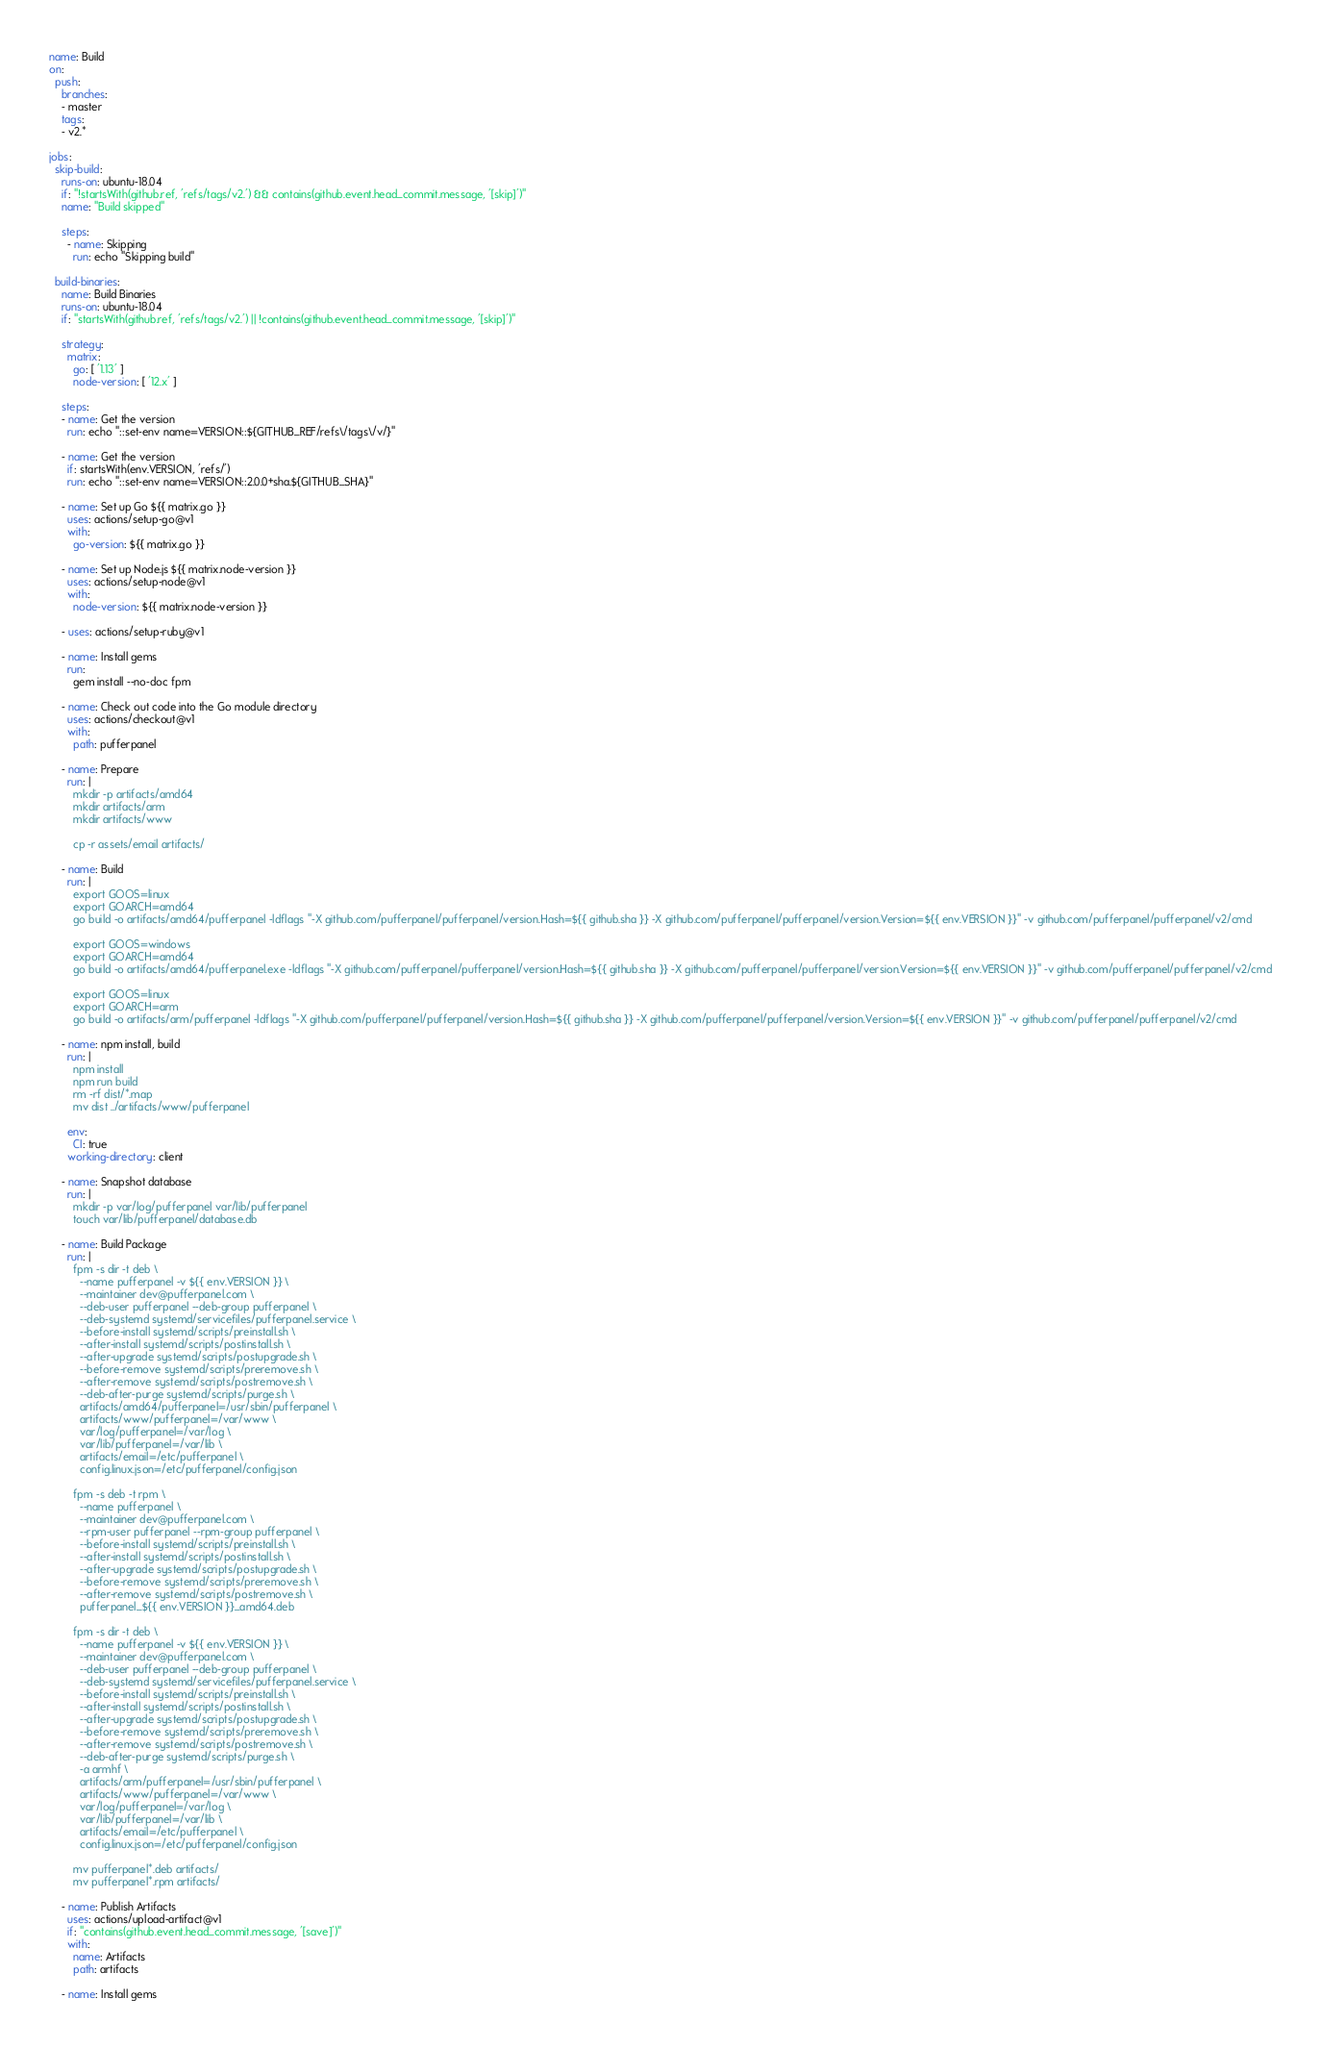<code> <loc_0><loc_0><loc_500><loc_500><_YAML_>name: Build
on: 
  push:
    branches:
    - master
    tags:
    - v2.*
    
jobs:
  skip-build:
    runs-on: ubuntu-18.04
    if: "!startsWith(github.ref, 'refs/tags/v2.') && contains(github.event.head_commit.message, '[skip]')"
    name: "Build skipped"

    steps:
      - name: Skipping
        run: echo "Skipping build"

  build-binaries:
    name: Build Binaries
    runs-on: ubuntu-18.04
    if: "startsWith(github.ref, 'refs/tags/v2.') || !contains(github.event.head_commit.message, '[skip]')"
    
    strategy:
      matrix:
        go: [ '1.13' ]
        node-version: [ '12.x' ]

    steps:
    - name: Get the version
      run: echo "::set-env name=VERSION::${GITHUB_REF/refs\/tags\/v/}"
    
    - name: Get the version
      if: startsWith(env.VERSION, 'refs/')
      run: echo "::set-env name=VERSION::2.0.0+sha.${GITHUB_SHA}"

    - name: Set up Go ${{ matrix.go }}
      uses: actions/setup-go@v1
      with:
        go-version: ${{ matrix.go }}

    - name: Set up Node.js ${{ matrix.node-version }}
      uses: actions/setup-node@v1
      with:
        node-version: ${{ matrix.node-version }}

    - uses: actions/setup-ruby@v1

    - name: Install gems
      run:
        gem install --no-doc fpm

    - name: Check out code into the Go module directory
      uses: actions/checkout@v1
      with:
        path: pufferpanel

    - name: Prepare
      run: |
        mkdir -p artifacts/amd64
        mkdir artifacts/arm
        mkdir artifacts/www

        cp -r assets/email artifacts/
        
    - name: Build
      run: |
        export GOOS=linux
        export GOARCH=amd64
        go build -o artifacts/amd64/pufferpanel -ldflags "-X github.com/pufferpanel/pufferpanel/version.Hash=${{ github.sha }} -X github.com/pufferpanel/pufferpanel/version.Version=${{ env.VERSION }}" -v github.com/pufferpanel/pufferpanel/v2/cmd

        export GOOS=windows
        export GOARCH=amd64
        go build -o artifacts/amd64/pufferpanel.exe -ldflags "-X github.com/pufferpanel/pufferpanel/version.Hash=${{ github.sha }} -X github.com/pufferpanel/pufferpanel/version.Version=${{ env.VERSION }}" -v github.com/pufferpanel/pufferpanel/v2/cmd

        export GOOS=linux
        export GOARCH=arm
        go build -o artifacts/arm/pufferpanel -ldflags "-X github.com/pufferpanel/pufferpanel/version.Hash=${{ github.sha }} -X github.com/pufferpanel/pufferpanel/version.Version=${{ env.VERSION }}" -v github.com/pufferpanel/pufferpanel/v2/cmd

    - name: npm install, build
      run: |
        npm install
        npm run build
        rm -rf dist/*.map
        mv dist ../artifacts/www/pufferpanel

      env:
        CI: true
      working-directory: client
  
    - name: Snapshot database
      run: |
        mkdir -p var/log/pufferpanel var/lib/pufferpanel
        touch var/lib/pufferpanel/database.db

    - name: Build Package
      run: |
        fpm -s dir -t deb \
          --name pufferpanel -v ${{ env.VERSION }} \
          --maintainer dev@pufferpanel.com \
          --deb-user pufferpanel --deb-group pufferpanel \
          --deb-systemd systemd/servicefiles/pufferpanel.service \
          --before-install systemd/scripts/preinstall.sh \
          --after-install systemd/scripts/postinstall.sh \
          --after-upgrade systemd/scripts/postupgrade.sh \
          --before-remove systemd/scripts/preremove.sh \
          --after-remove systemd/scripts/postremove.sh \
          --deb-after-purge systemd/scripts/purge.sh \
          artifacts/amd64/pufferpanel=/usr/sbin/pufferpanel \
          artifacts/www/pufferpanel=/var/www \
          var/log/pufferpanel=/var/log \
          var/lib/pufferpanel=/var/lib \
          artifacts/email=/etc/pufferpanel \
          config.linux.json=/etc/pufferpanel/config.json

        fpm -s deb -t rpm \
          --name pufferpanel \
          --maintainer dev@pufferpanel.com \
          --rpm-user pufferpanel --rpm-group pufferpanel \
          --before-install systemd/scripts/preinstall.sh \
          --after-install systemd/scripts/postinstall.sh \
          --after-upgrade systemd/scripts/postupgrade.sh \
          --before-remove systemd/scripts/preremove.sh \
          --after-remove systemd/scripts/postremove.sh \
          pufferpanel_${{ env.VERSION }}_amd64.deb

        fpm -s dir -t deb \
          --name pufferpanel -v ${{ env.VERSION }} \
          --maintainer dev@pufferpanel.com \
          --deb-user pufferpanel --deb-group pufferpanel \
          --deb-systemd systemd/servicefiles/pufferpanel.service \
          --before-install systemd/scripts/preinstall.sh \
          --after-install systemd/scripts/postinstall.sh \
          --after-upgrade systemd/scripts/postupgrade.sh \
          --before-remove systemd/scripts/preremove.sh \
          --after-remove systemd/scripts/postremove.sh \
          --deb-after-purge systemd/scripts/purge.sh \
          -a armhf \
          artifacts/arm/pufferpanel=/usr/sbin/pufferpanel \
          artifacts/www/pufferpanel=/var/www \
          var/log/pufferpanel=/var/log \
          var/lib/pufferpanel=/var/lib \
          artifacts/email=/etc/pufferpanel \
          config.linux.json=/etc/pufferpanel/config.json

        mv pufferpanel*.deb artifacts/
        mv pufferpanel*.rpm artifacts/

    - name: Publish Artifacts
      uses: actions/upload-artifact@v1
      if: "contains(github.event.head_commit.message, '[save]')"
      with:
        name: Artifacts
        path: artifacts

    - name: Install gems</code> 